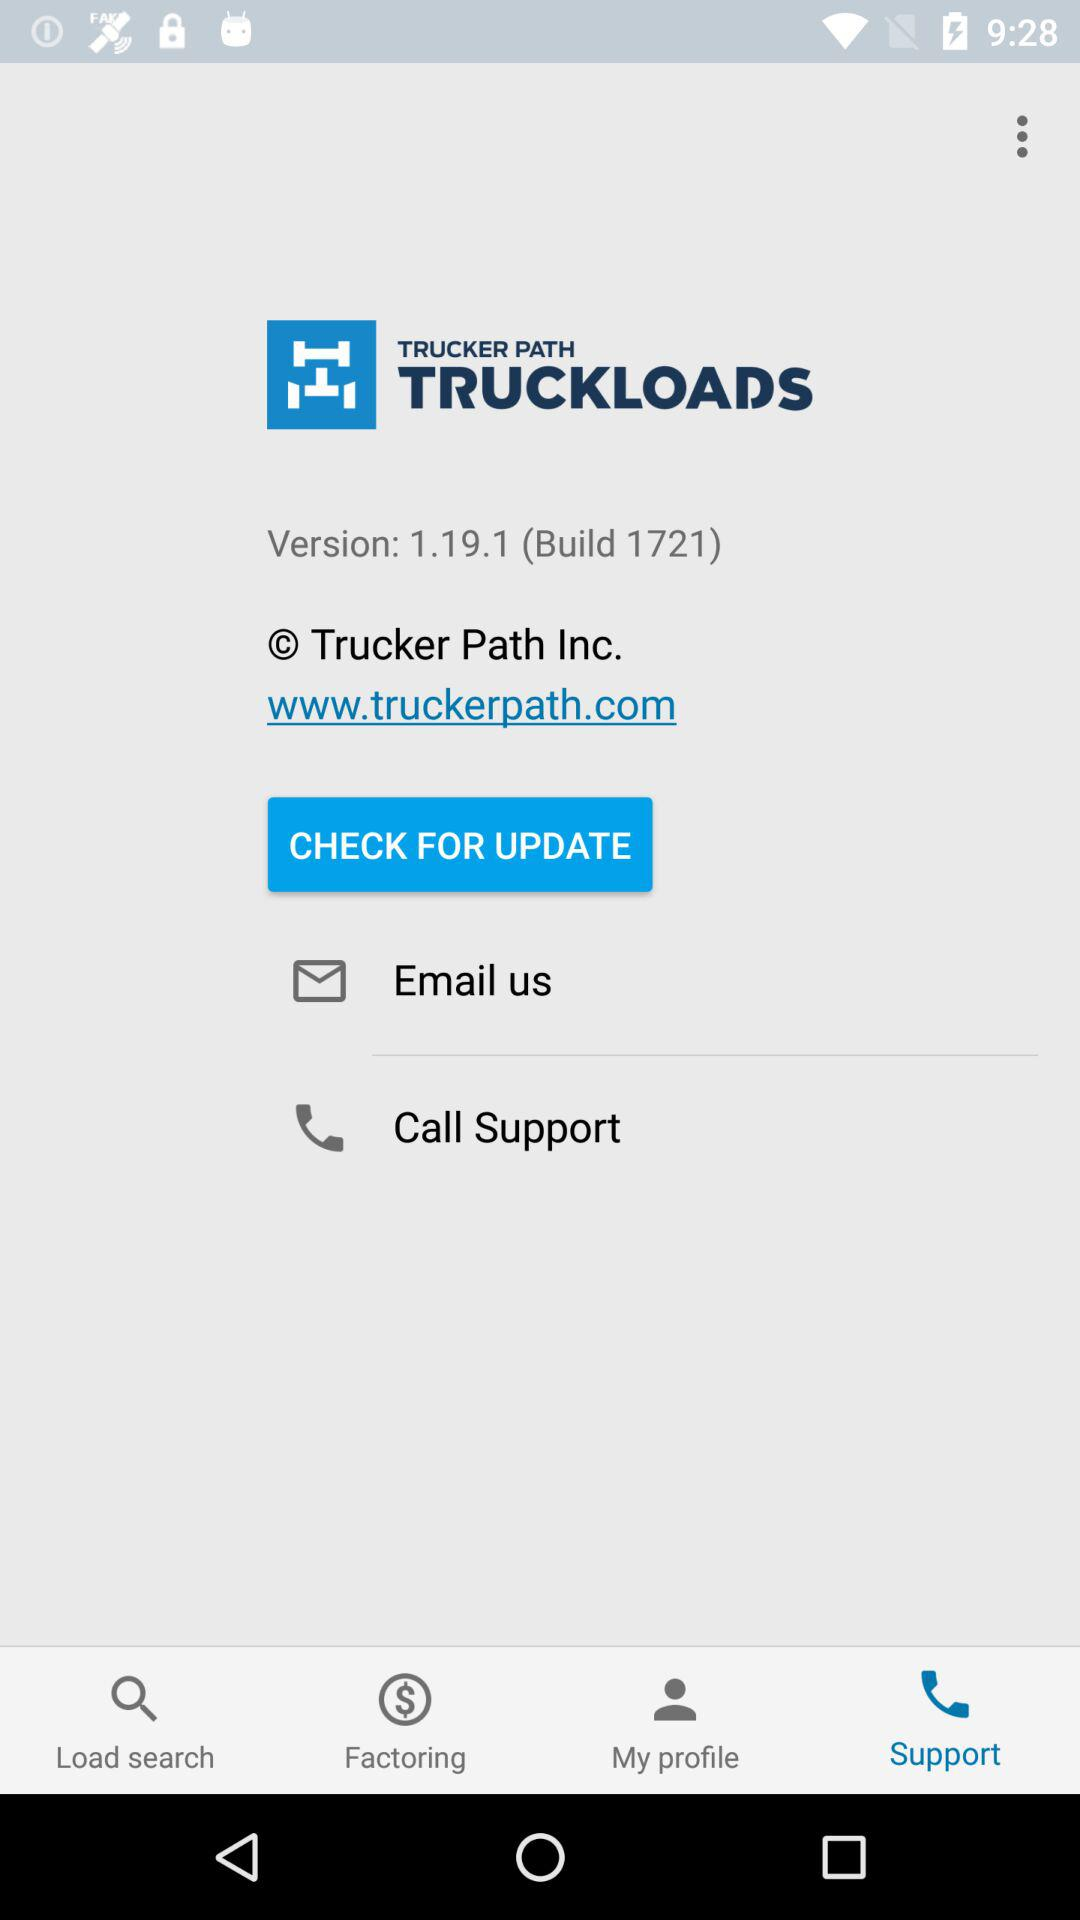Which tab is selected? The selected tab is "Support". 